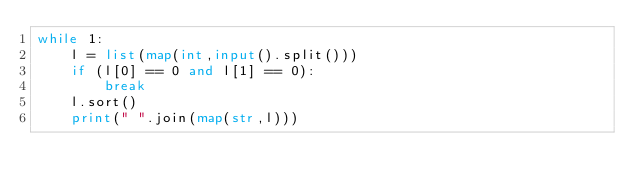<code> <loc_0><loc_0><loc_500><loc_500><_Python_>while 1:
    l = list(map(int,input().split()))
    if (l[0] == 0 and l[1] == 0):
        break
    l.sort()
    print(" ".join(map(str,l)))</code> 